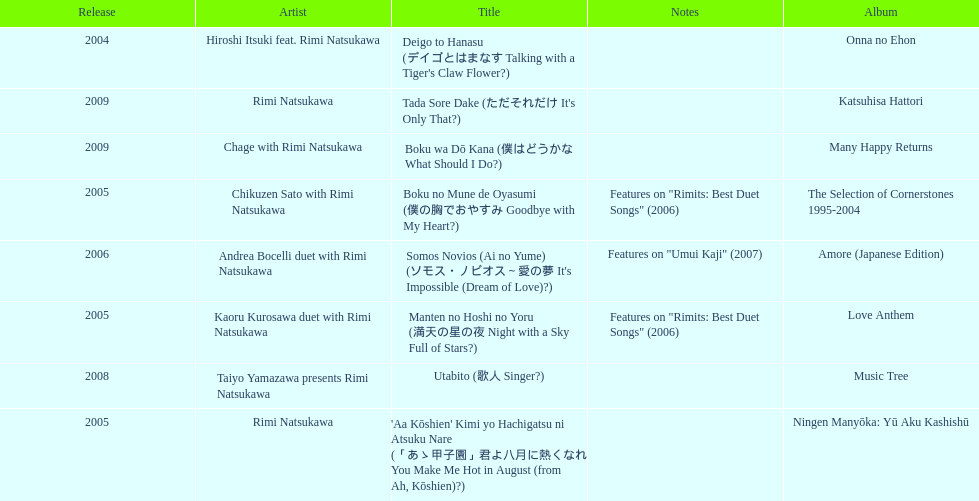Which year had the most titles released? 2005. 